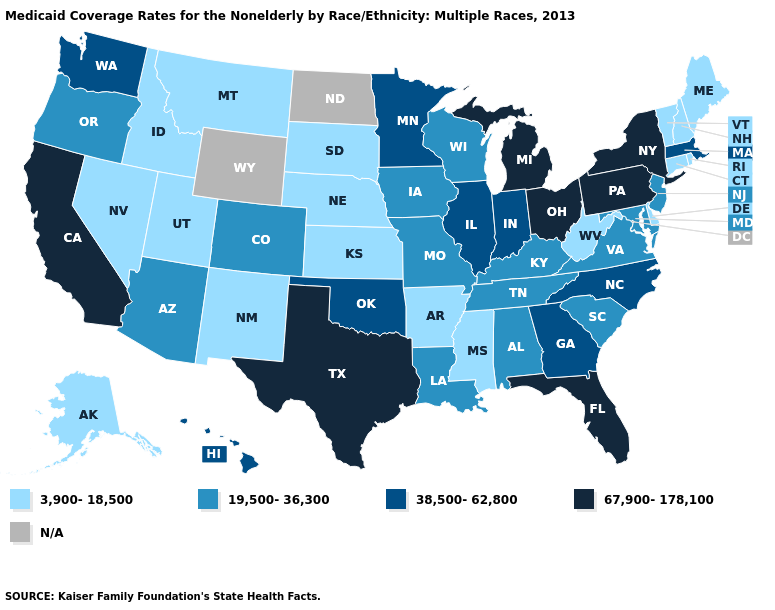Name the states that have a value in the range 3,900-18,500?
Quick response, please. Alaska, Arkansas, Connecticut, Delaware, Idaho, Kansas, Maine, Mississippi, Montana, Nebraska, Nevada, New Hampshire, New Mexico, Rhode Island, South Dakota, Utah, Vermont, West Virginia. Name the states that have a value in the range N/A?
Answer briefly. North Dakota, Wyoming. What is the highest value in states that border Minnesota?
Give a very brief answer. 19,500-36,300. Does Virginia have the lowest value in the USA?
Concise answer only. No. What is the value of Nevada?
Quick response, please. 3,900-18,500. Does North Carolina have the lowest value in the South?
Be succinct. No. Among the states that border Virginia , which have the lowest value?
Quick response, please. West Virginia. Which states hav the highest value in the Northeast?
Write a very short answer. New York, Pennsylvania. What is the value of Nebraska?
Keep it brief. 3,900-18,500. What is the value of Arkansas?
Quick response, please. 3,900-18,500. Name the states that have a value in the range 3,900-18,500?
Short answer required. Alaska, Arkansas, Connecticut, Delaware, Idaho, Kansas, Maine, Mississippi, Montana, Nebraska, Nevada, New Hampshire, New Mexico, Rhode Island, South Dakota, Utah, Vermont, West Virginia. Which states have the lowest value in the Northeast?
Be succinct. Connecticut, Maine, New Hampshire, Rhode Island, Vermont. What is the value of Louisiana?
Keep it brief. 19,500-36,300. 